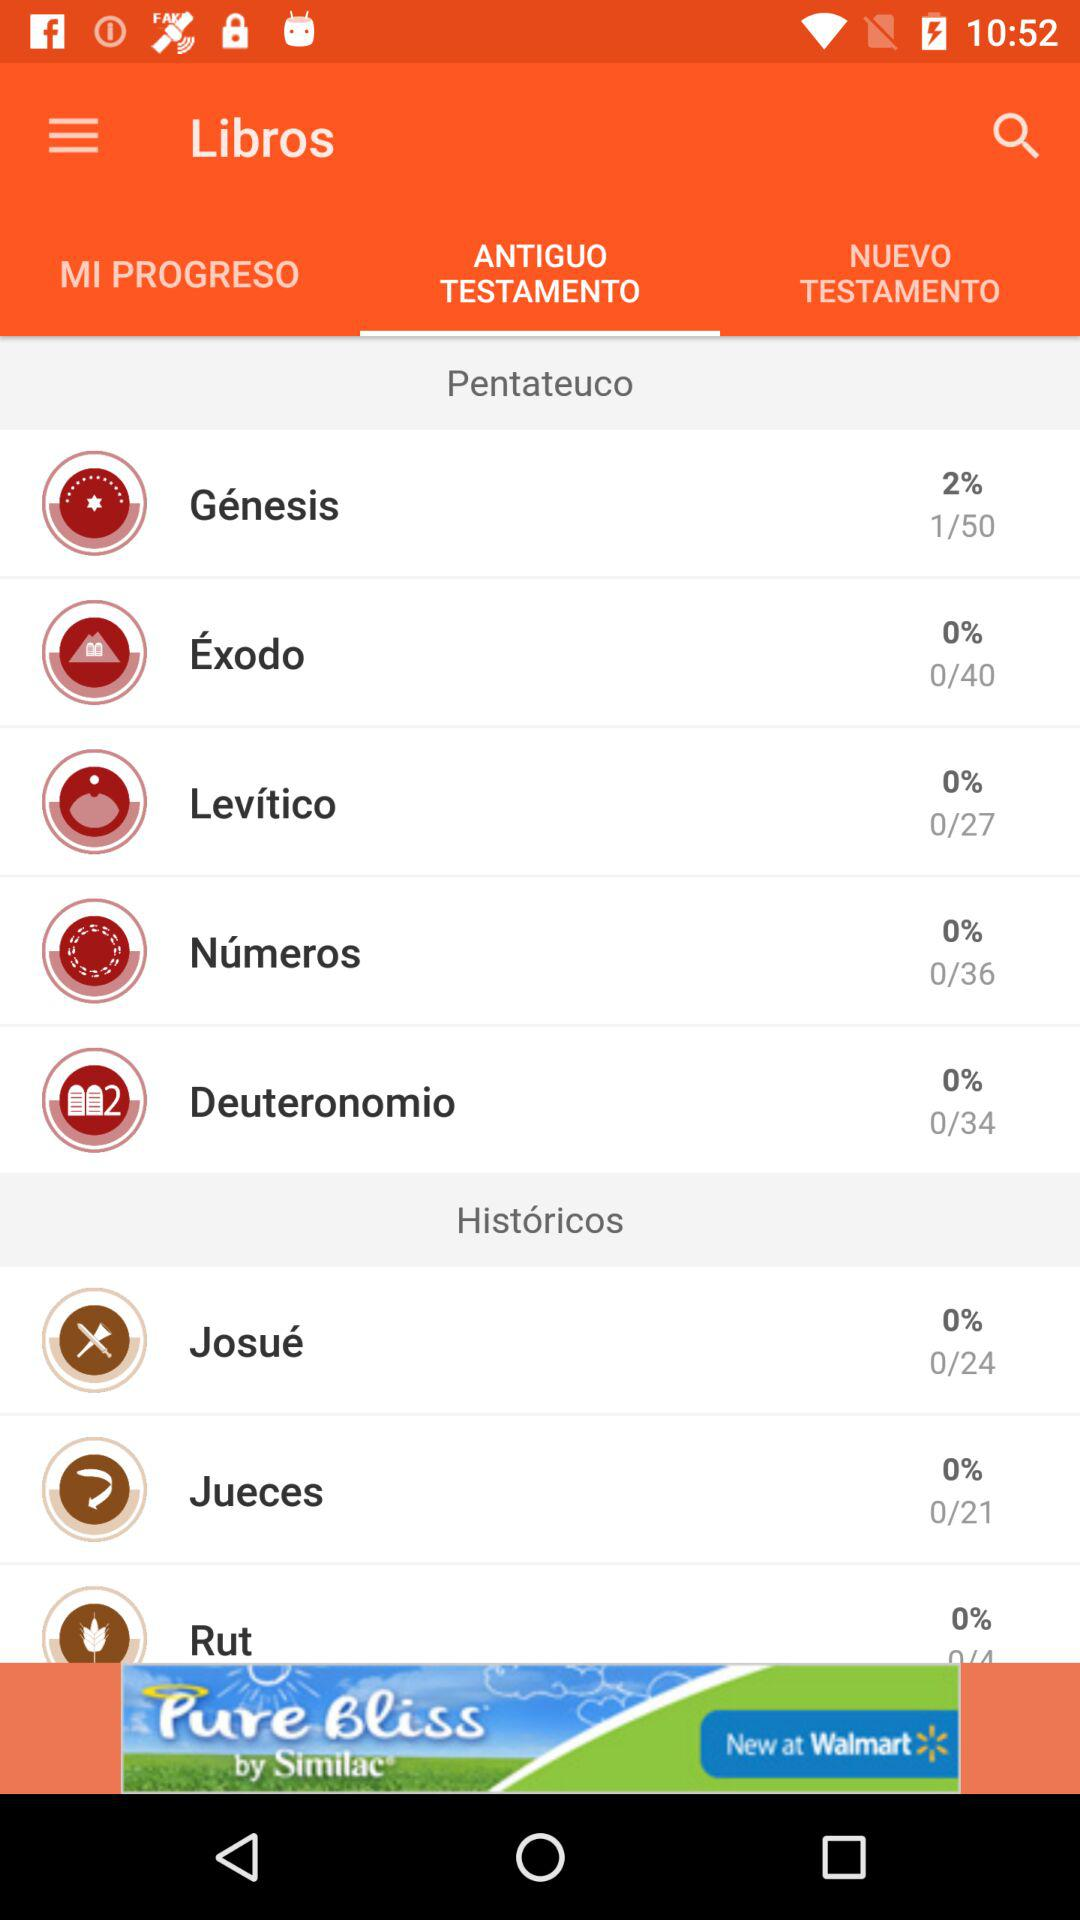How many books are in the Pentateuco?
Answer the question using a single word or phrase. 5 